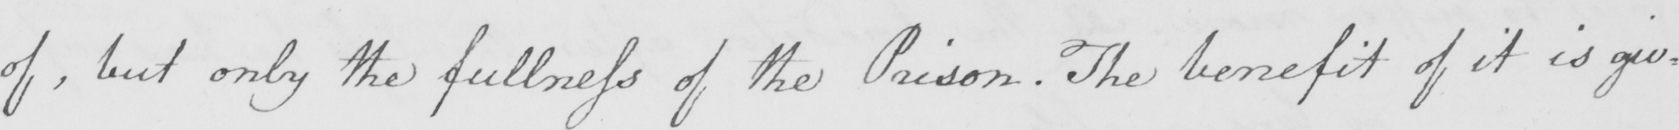Transcribe the text shown in this historical manuscript line. of , but only the fullness of the Prison . The benefit of it is giv= 